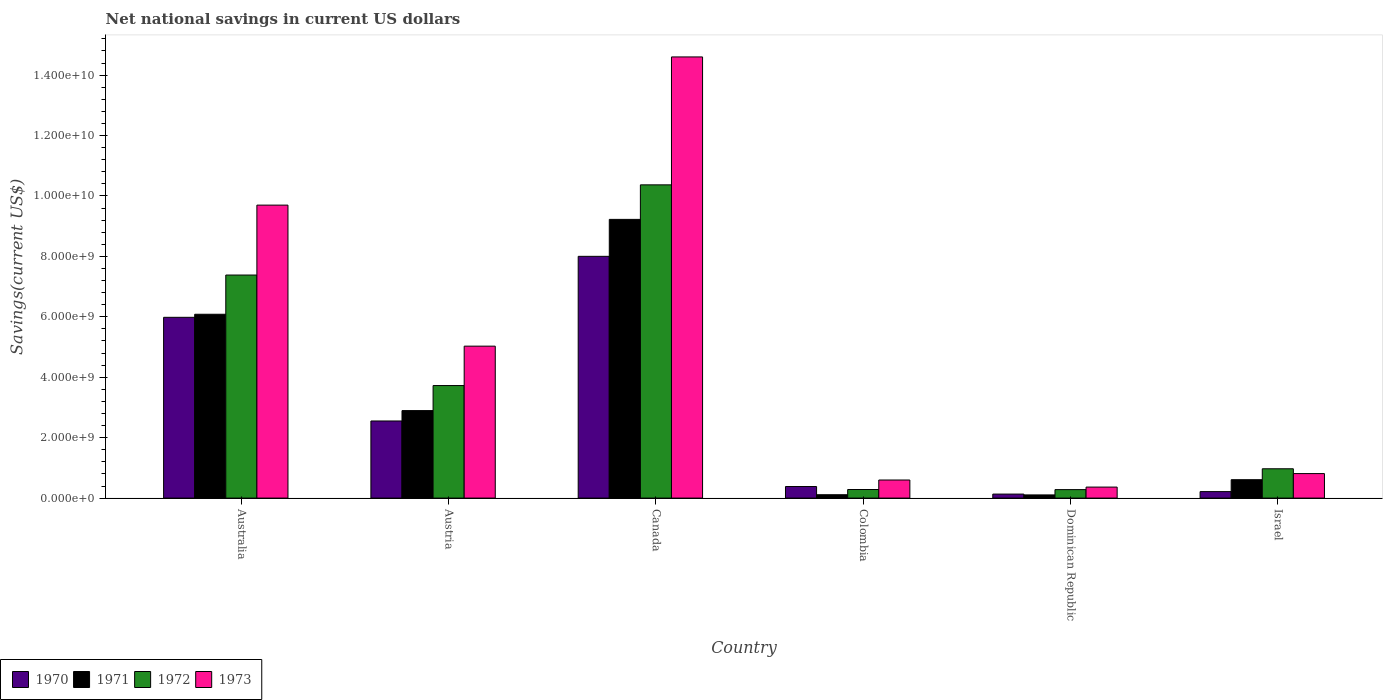How many different coloured bars are there?
Your response must be concise. 4. How many groups of bars are there?
Make the answer very short. 6. Are the number of bars on each tick of the X-axis equal?
Your answer should be compact. Yes. What is the label of the 6th group of bars from the left?
Keep it short and to the point. Israel. In how many cases, is the number of bars for a given country not equal to the number of legend labels?
Ensure brevity in your answer.  0. What is the net national savings in 1971 in Canada?
Provide a short and direct response. 9.23e+09. Across all countries, what is the maximum net national savings in 1973?
Give a very brief answer. 1.46e+1. Across all countries, what is the minimum net national savings in 1972?
Offer a very short reply. 2.80e+08. In which country was the net national savings in 1970 maximum?
Your answer should be very brief. Canada. In which country was the net national savings in 1973 minimum?
Offer a very short reply. Dominican Republic. What is the total net national savings in 1971 in the graph?
Make the answer very short. 1.90e+1. What is the difference between the net national savings in 1973 in Canada and that in Israel?
Provide a short and direct response. 1.38e+1. What is the difference between the net national savings in 1971 in Israel and the net national savings in 1970 in Dominican Republic?
Give a very brief answer. 4.76e+08. What is the average net national savings in 1972 per country?
Make the answer very short. 3.84e+09. What is the difference between the net national savings of/in 1973 and net national savings of/in 1970 in Dominican Republic?
Give a very brief answer. 2.32e+08. In how many countries, is the net national savings in 1972 greater than 9600000000 US$?
Offer a very short reply. 1. What is the ratio of the net national savings in 1972 in Canada to that in Dominican Republic?
Your answer should be very brief. 36.96. Is the net national savings in 1971 in Austria less than that in Colombia?
Keep it short and to the point. No. Is the difference between the net national savings in 1973 in Colombia and Dominican Republic greater than the difference between the net national savings in 1970 in Colombia and Dominican Republic?
Provide a succinct answer. No. What is the difference between the highest and the second highest net national savings in 1971?
Your answer should be very brief. 3.19e+09. What is the difference between the highest and the lowest net national savings in 1972?
Ensure brevity in your answer.  1.01e+1. In how many countries, is the net national savings in 1971 greater than the average net national savings in 1971 taken over all countries?
Make the answer very short. 2. Is the sum of the net national savings in 1971 in Australia and Canada greater than the maximum net national savings in 1972 across all countries?
Your answer should be very brief. Yes. What does the 3rd bar from the right in Colombia represents?
Provide a short and direct response. 1971. Are all the bars in the graph horizontal?
Your answer should be compact. No. How many countries are there in the graph?
Your answer should be very brief. 6. Are the values on the major ticks of Y-axis written in scientific E-notation?
Your answer should be compact. Yes. Does the graph contain any zero values?
Your response must be concise. No. Does the graph contain grids?
Provide a succinct answer. No. Where does the legend appear in the graph?
Make the answer very short. Bottom left. How many legend labels are there?
Your response must be concise. 4. How are the legend labels stacked?
Offer a terse response. Horizontal. What is the title of the graph?
Offer a very short reply. Net national savings in current US dollars. Does "1999" appear as one of the legend labels in the graph?
Give a very brief answer. No. What is the label or title of the Y-axis?
Your answer should be compact. Savings(current US$). What is the Savings(current US$) of 1970 in Australia?
Your answer should be very brief. 5.98e+09. What is the Savings(current US$) of 1971 in Australia?
Your response must be concise. 6.09e+09. What is the Savings(current US$) of 1972 in Australia?
Your response must be concise. 7.38e+09. What is the Savings(current US$) in 1973 in Australia?
Provide a short and direct response. 9.70e+09. What is the Savings(current US$) of 1970 in Austria?
Your answer should be very brief. 2.55e+09. What is the Savings(current US$) of 1971 in Austria?
Keep it short and to the point. 2.90e+09. What is the Savings(current US$) in 1972 in Austria?
Offer a terse response. 3.73e+09. What is the Savings(current US$) of 1973 in Austria?
Provide a succinct answer. 5.03e+09. What is the Savings(current US$) in 1970 in Canada?
Your answer should be compact. 8.00e+09. What is the Savings(current US$) in 1971 in Canada?
Provide a short and direct response. 9.23e+09. What is the Savings(current US$) in 1972 in Canada?
Your answer should be very brief. 1.04e+1. What is the Savings(current US$) in 1973 in Canada?
Provide a succinct answer. 1.46e+1. What is the Savings(current US$) in 1970 in Colombia?
Make the answer very short. 3.83e+08. What is the Savings(current US$) of 1971 in Colombia?
Keep it short and to the point. 1.11e+08. What is the Savings(current US$) in 1972 in Colombia?
Your response must be concise. 2.84e+08. What is the Savings(current US$) in 1973 in Colombia?
Make the answer very short. 5.98e+08. What is the Savings(current US$) in 1970 in Dominican Republic?
Make the answer very short. 1.33e+08. What is the Savings(current US$) of 1971 in Dominican Republic?
Provide a succinct answer. 1.05e+08. What is the Savings(current US$) of 1972 in Dominican Republic?
Your answer should be compact. 2.80e+08. What is the Savings(current US$) of 1973 in Dominican Republic?
Your answer should be very brief. 3.65e+08. What is the Savings(current US$) of 1970 in Israel?
Make the answer very short. 2.15e+08. What is the Savings(current US$) of 1971 in Israel?
Offer a terse response. 6.09e+08. What is the Savings(current US$) of 1972 in Israel?
Offer a very short reply. 9.71e+08. What is the Savings(current US$) of 1973 in Israel?
Give a very brief answer. 8.11e+08. Across all countries, what is the maximum Savings(current US$) of 1970?
Offer a terse response. 8.00e+09. Across all countries, what is the maximum Savings(current US$) in 1971?
Keep it short and to the point. 9.23e+09. Across all countries, what is the maximum Savings(current US$) in 1972?
Your response must be concise. 1.04e+1. Across all countries, what is the maximum Savings(current US$) of 1973?
Offer a terse response. 1.46e+1. Across all countries, what is the minimum Savings(current US$) in 1970?
Make the answer very short. 1.33e+08. Across all countries, what is the minimum Savings(current US$) in 1971?
Provide a succinct answer. 1.05e+08. Across all countries, what is the minimum Savings(current US$) of 1972?
Make the answer very short. 2.80e+08. Across all countries, what is the minimum Savings(current US$) of 1973?
Your response must be concise. 3.65e+08. What is the total Savings(current US$) in 1970 in the graph?
Offer a very short reply. 1.73e+1. What is the total Savings(current US$) of 1971 in the graph?
Offer a terse response. 1.90e+1. What is the total Savings(current US$) in 1972 in the graph?
Your answer should be very brief. 2.30e+1. What is the total Savings(current US$) of 1973 in the graph?
Keep it short and to the point. 3.11e+1. What is the difference between the Savings(current US$) of 1970 in Australia and that in Austria?
Provide a succinct answer. 3.43e+09. What is the difference between the Savings(current US$) of 1971 in Australia and that in Austria?
Your response must be concise. 3.19e+09. What is the difference between the Savings(current US$) of 1972 in Australia and that in Austria?
Keep it short and to the point. 3.66e+09. What is the difference between the Savings(current US$) of 1973 in Australia and that in Austria?
Provide a short and direct response. 4.67e+09. What is the difference between the Savings(current US$) of 1970 in Australia and that in Canada?
Ensure brevity in your answer.  -2.02e+09. What is the difference between the Savings(current US$) in 1971 in Australia and that in Canada?
Ensure brevity in your answer.  -3.14e+09. What is the difference between the Savings(current US$) of 1972 in Australia and that in Canada?
Your response must be concise. -2.99e+09. What is the difference between the Savings(current US$) of 1973 in Australia and that in Canada?
Your answer should be very brief. -4.90e+09. What is the difference between the Savings(current US$) of 1970 in Australia and that in Colombia?
Make the answer very short. 5.60e+09. What is the difference between the Savings(current US$) of 1971 in Australia and that in Colombia?
Offer a terse response. 5.97e+09. What is the difference between the Savings(current US$) of 1972 in Australia and that in Colombia?
Your answer should be compact. 7.10e+09. What is the difference between the Savings(current US$) in 1973 in Australia and that in Colombia?
Your response must be concise. 9.10e+09. What is the difference between the Savings(current US$) in 1970 in Australia and that in Dominican Republic?
Provide a succinct answer. 5.85e+09. What is the difference between the Savings(current US$) of 1971 in Australia and that in Dominican Republic?
Ensure brevity in your answer.  5.98e+09. What is the difference between the Savings(current US$) in 1972 in Australia and that in Dominican Republic?
Your answer should be very brief. 7.10e+09. What is the difference between the Savings(current US$) in 1973 in Australia and that in Dominican Republic?
Offer a very short reply. 9.33e+09. What is the difference between the Savings(current US$) in 1970 in Australia and that in Israel?
Provide a succinct answer. 5.77e+09. What is the difference between the Savings(current US$) in 1971 in Australia and that in Israel?
Your response must be concise. 5.48e+09. What is the difference between the Savings(current US$) in 1972 in Australia and that in Israel?
Provide a short and direct response. 6.41e+09. What is the difference between the Savings(current US$) of 1973 in Australia and that in Israel?
Offer a very short reply. 8.89e+09. What is the difference between the Savings(current US$) in 1970 in Austria and that in Canada?
Provide a succinct answer. -5.45e+09. What is the difference between the Savings(current US$) of 1971 in Austria and that in Canada?
Your answer should be compact. -6.33e+09. What is the difference between the Savings(current US$) of 1972 in Austria and that in Canada?
Give a very brief answer. -6.64e+09. What is the difference between the Savings(current US$) of 1973 in Austria and that in Canada?
Ensure brevity in your answer.  -9.57e+09. What is the difference between the Savings(current US$) of 1970 in Austria and that in Colombia?
Offer a terse response. 2.17e+09. What is the difference between the Savings(current US$) in 1971 in Austria and that in Colombia?
Offer a terse response. 2.78e+09. What is the difference between the Savings(current US$) in 1972 in Austria and that in Colombia?
Ensure brevity in your answer.  3.44e+09. What is the difference between the Savings(current US$) of 1973 in Austria and that in Colombia?
Make the answer very short. 4.43e+09. What is the difference between the Savings(current US$) of 1970 in Austria and that in Dominican Republic?
Provide a succinct answer. 2.42e+09. What is the difference between the Savings(current US$) of 1971 in Austria and that in Dominican Republic?
Make the answer very short. 2.79e+09. What is the difference between the Savings(current US$) of 1972 in Austria and that in Dominican Republic?
Provide a short and direct response. 3.44e+09. What is the difference between the Savings(current US$) in 1973 in Austria and that in Dominican Republic?
Provide a short and direct response. 4.66e+09. What is the difference between the Savings(current US$) in 1970 in Austria and that in Israel?
Give a very brief answer. 2.34e+09. What is the difference between the Savings(current US$) in 1971 in Austria and that in Israel?
Your answer should be very brief. 2.29e+09. What is the difference between the Savings(current US$) in 1972 in Austria and that in Israel?
Your answer should be very brief. 2.75e+09. What is the difference between the Savings(current US$) in 1973 in Austria and that in Israel?
Your answer should be compact. 4.22e+09. What is the difference between the Savings(current US$) of 1970 in Canada and that in Colombia?
Your answer should be very brief. 7.62e+09. What is the difference between the Savings(current US$) in 1971 in Canada and that in Colombia?
Provide a succinct answer. 9.11e+09. What is the difference between the Savings(current US$) of 1972 in Canada and that in Colombia?
Your answer should be compact. 1.01e+1. What is the difference between the Savings(current US$) of 1973 in Canada and that in Colombia?
Make the answer very short. 1.40e+1. What is the difference between the Savings(current US$) of 1970 in Canada and that in Dominican Republic?
Your response must be concise. 7.87e+09. What is the difference between the Savings(current US$) in 1971 in Canada and that in Dominican Republic?
Your answer should be very brief. 9.12e+09. What is the difference between the Savings(current US$) in 1972 in Canada and that in Dominican Republic?
Keep it short and to the point. 1.01e+1. What is the difference between the Savings(current US$) in 1973 in Canada and that in Dominican Republic?
Keep it short and to the point. 1.42e+1. What is the difference between the Savings(current US$) of 1970 in Canada and that in Israel?
Provide a short and direct response. 7.79e+09. What is the difference between the Savings(current US$) in 1971 in Canada and that in Israel?
Provide a short and direct response. 8.62e+09. What is the difference between the Savings(current US$) of 1972 in Canada and that in Israel?
Keep it short and to the point. 9.40e+09. What is the difference between the Savings(current US$) of 1973 in Canada and that in Israel?
Provide a short and direct response. 1.38e+1. What is the difference between the Savings(current US$) in 1970 in Colombia and that in Dominican Republic?
Provide a succinct answer. 2.50e+08. What is the difference between the Savings(current US$) in 1971 in Colombia and that in Dominican Republic?
Your response must be concise. 6.03e+06. What is the difference between the Savings(current US$) in 1972 in Colombia and that in Dominican Republic?
Provide a succinct answer. 3.48e+06. What is the difference between the Savings(current US$) of 1973 in Colombia and that in Dominican Republic?
Provide a succinct answer. 2.34e+08. What is the difference between the Savings(current US$) in 1970 in Colombia and that in Israel?
Your answer should be very brief. 1.68e+08. What is the difference between the Savings(current US$) of 1971 in Colombia and that in Israel?
Make the answer very short. -4.97e+08. What is the difference between the Savings(current US$) of 1972 in Colombia and that in Israel?
Provide a short and direct response. -6.87e+08. What is the difference between the Savings(current US$) in 1973 in Colombia and that in Israel?
Offer a terse response. -2.12e+08. What is the difference between the Savings(current US$) of 1970 in Dominican Republic and that in Israel?
Your response must be concise. -8.19e+07. What is the difference between the Savings(current US$) of 1971 in Dominican Republic and that in Israel?
Your answer should be very brief. -5.03e+08. What is the difference between the Savings(current US$) in 1972 in Dominican Republic and that in Israel?
Offer a terse response. -6.90e+08. What is the difference between the Savings(current US$) of 1973 in Dominican Republic and that in Israel?
Your answer should be very brief. -4.46e+08. What is the difference between the Savings(current US$) of 1970 in Australia and the Savings(current US$) of 1971 in Austria?
Provide a succinct answer. 3.09e+09. What is the difference between the Savings(current US$) of 1970 in Australia and the Savings(current US$) of 1972 in Austria?
Your response must be concise. 2.26e+09. What is the difference between the Savings(current US$) in 1970 in Australia and the Savings(current US$) in 1973 in Austria?
Offer a terse response. 9.54e+08. What is the difference between the Savings(current US$) of 1971 in Australia and the Savings(current US$) of 1972 in Austria?
Offer a very short reply. 2.36e+09. What is the difference between the Savings(current US$) of 1971 in Australia and the Savings(current US$) of 1973 in Austria?
Ensure brevity in your answer.  1.06e+09. What is the difference between the Savings(current US$) of 1972 in Australia and the Savings(current US$) of 1973 in Austria?
Ensure brevity in your answer.  2.35e+09. What is the difference between the Savings(current US$) in 1970 in Australia and the Savings(current US$) in 1971 in Canada?
Make the answer very short. -3.24e+09. What is the difference between the Savings(current US$) in 1970 in Australia and the Savings(current US$) in 1972 in Canada?
Make the answer very short. -4.38e+09. What is the difference between the Savings(current US$) of 1970 in Australia and the Savings(current US$) of 1973 in Canada?
Make the answer very short. -8.62e+09. What is the difference between the Savings(current US$) of 1971 in Australia and the Savings(current US$) of 1972 in Canada?
Provide a succinct answer. -4.28e+09. What is the difference between the Savings(current US$) in 1971 in Australia and the Savings(current US$) in 1973 in Canada?
Make the answer very short. -8.52e+09. What is the difference between the Savings(current US$) in 1972 in Australia and the Savings(current US$) in 1973 in Canada?
Offer a very short reply. -7.22e+09. What is the difference between the Savings(current US$) of 1970 in Australia and the Savings(current US$) of 1971 in Colombia?
Provide a short and direct response. 5.87e+09. What is the difference between the Savings(current US$) in 1970 in Australia and the Savings(current US$) in 1972 in Colombia?
Your answer should be very brief. 5.70e+09. What is the difference between the Savings(current US$) in 1970 in Australia and the Savings(current US$) in 1973 in Colombia?
Keep it short and to the point. 5.38e+09. What is the difference between the Savings(current US$) in 1971 in Australia and the Savings(current US$) in 1972 in Colombia?
Your answer should be very brief. 5.80e+09. What is the difference between the Savings(current US$) of 1971 in Australia and the Savings(current US$) of 1973 in Colombia?
Your answer should be very brief. 5.49e+09. What is the difference between the Savings(current US$) in 1972 in Australia and the Savings(current US$) in 1973 in Colombia?
Give a very brief answer. 6.78e+09. What is the difference between the Savings(current US$) in 1970 in Australia and the Savings(current US$) in 1971 in Dominican Republic?
Provide a short and direct response. 5.88e+09. What is the difference between the Savings(current US$) in 1970 in Australia and the Savings(current US$) in 1972 in Dominican Republic?
Provide a succinct answer. 5.70e+09. What is the difference between the Savings(current US$) of 1970 in Australia and the Savings(current US$) of 1973 in Dominican Republic?
Your answer should be compact. 5.62e+09. What is the difference between the Savings(current US$) in 1971 in Australia and the Savings(current US$) in 1972 in Dominican Republic?
Make the answer very short. 5.80e+09. What is the difference between the Savings(current US$) of 1971 in Australia and the Savings(current US$) of 1973 in Dominican Republic?
Your answer should be very brief. 5.72e+09. What is the difference between the Savings(current US$) in 1972 in Australia and the Savings(current US$) in 1973 in Dominican Republic?
Keep it short and to the point. 7.02e+09. What is the difference between the Savings(current US$) in 1970 in Australia and the Savings(current US$) in 1971 in Israel?
Offer a very short reply. 5.37e+09. What is the difference between the Savings(current US$) of 1970 in Australia and the Savings(current US$) of 1972 in Israel?
Your answer should be very brief. 5.01e+09. What is the difference between the Savings(current US$) in 1970 in Australia and the Savings(current US$) in 1973 in Israel?
Offer a very short reply. 5.17e+09. What is the difference between the Savings(current US$) of 1971 in Australia and the Savings(current US$) of 1972 in Israel?
Provide a succinct answer. 5.11e+09. What is the difference between the Savings(current US$) in 1971 in Australia and the Savings(current US$) in 1973 in Israel?
Give a very brief answer. 5.27e+09. What is the difference between the Savings(current US$) in 1972 in Australia and the Savings(current US$) in 1973 in Israel?
Your answer should be very brief. 6.57e+09. What is the difference between the Savings(current US$) of 1970 in Austria and the Savings(current US$) of 1971 in Canada?
Provide a succinct answer. -6.67e+09. What is the difference between the Savings(current US$) in 1970 in Austria and the Savings(current US$) in 1972 in Canada?
Ensure brevity in your answer.  -7.82e+09. What is the difference between the Savings(current US$) of 1970 in Austria and the Savings(current US$) of 1973 in Canada?
Your answer should be very brief. -1.20e+1. What is the difference between the Savings(current US$) in 1971 in Austria and the Savings(current US$) in 1972 in Canada?
Your answer should be very brief. -7.47e+09. What is the difference between the Savings(current US$) of 1971 in Austria and the Savings(current US$) of 1973 in Canada?
Keep it short and to the point. -1.17e+1. What is the difference between the Savings(current US$) of 1972 in Austria and the Savings(current US$) of 1973 in Canada?
Your response must be concise. -1.09e+1. What is the difference between the Savings(current US$) in 1970 in Austria and the Savings(current US$) in 1971 in Colombia?
Offer a very short reply. 2.44e+09. What is the difference between the Savings(current US$) in 1970 in Austria and the Savings(current US$) in 1972 in Colombia?
Your answer should be very brief. 2.27e+09. What is the difference between the Savings(current US$) in 1970 in Austria and the Savings(current US$) in 1973 in Colombia?
Your answer should be compact. 1.95e+09. What is the difference between the Savings(current US$) of 1971 in Austria and the Savings(current US$) of 1972 in Colombia?
Keep it short and to the point. 2.61e+09. What is the difference between the Savings(current US$) of 1971 in Austria and the Savings(current US$) of 1973 in Colombia?
Give a very brief answer. 2.30e+09. What is the difference between the Savings(current US$) of 1972 in Austria and the Savings(current US$) of 1973 in Colombia?
Offer a terse response. 3.13e+09. What is the difference between the Savings(current US$) of 1970 in Austria and the Savings(current US$) of 1971 in Dominican Republic?
Make the answer very short. 2.45e+09. What is the difference between the Savings(current US$) in 1970 in Austria and the Savings(current US$) in 1972 in Dominican Republic?
Give a very brief answer. 2.27e+09. What is the difference between the Savings(current US$) of 1970 in Austria and the Savings(current US$) of 1973 in Dominican Republic?
Offer a terse response. 2.19e+09. What is the difference between the Savings(current US$) of 1971 in Austria and the Savings(current US$) of 1972 in Dominican Republic?
Make the answer very short. 2.62e+09. What is the difference between the Savings(current US$) in 1971 in Austria and the Savings(current US$) in 1973 in Dominican Republic?
Offer a very short reply. 2.53e+09. What is the difference between the Savings(current US$) in 1972 in Austria and the Savings(current US$) in 1973 in Dominican Republic?
Offer a terse response. 3.36e+09. What is the difference between the Savings(current US$) of 1970 in Austria and the Savings(current US$) of 1971 in Israel?
Your response must be concise. 1.94e+09. What is the difference between the Savings(current US$) of 1970 in Austria and the Savings(current US$) of 1972 in Israel?
Offer a terse response. 1.58e+09. What is the difference between the Savings(current US$) of 1970 in Austria and the Savings(current US$) of 1973 in Israel?
Keep it short and to the point. 1.74e+09. What is the difference between the Savings(current US$) in 1971 in Austria and the Savings(current US$) in 1972 in Israel?
Make the answer very short. 1.93e+09. What is the difference between the Savings(current US$) of 1971 in Austria and the Savings(current US$) of 1973 in Israel?
Offer a very short reply. 2.09e+09. What is the difference between the Savings(current US$) of 1972 in Austria and the Savings(current US$) of 1973 in Israel?
Ensure brevity in your answer.  2.91e+09. What is the difference between the Savings(current US$) in 1970 in Canada and the Savings(current US$) in 1971 in Colombia?
Offer a very short reply. 7.89e+09. What is the difference between the Savings(current US$) in 1970 in Canada and the Savings(current US$) in 1972 in Colombia?
Provide a short and direct response. 7.72e+09. What is the difference between the Savings(current US$) of 1970 in Canada and the Savings(current US$) of 1973 in Colombia?
Provide a short and direct response. 7.40e+09. What is the difference between the Savings(current US$) in 1971 in Canada and the Savings(current US$) in 1972 in Colombia?
Your answer should be compact. 8.94e+09. What is the difference between the Savings(current US$) of 1971 in Canada and the Savings(current US$) of 1973 in Colombia?
Make the answer very short. 8.63e+09. What is the difference between the Savings(current US$) of 1972 in Canada and the Savings(current US$) of 1973 in Colombia?
Offer a terse response. 9.77e+09. What is the difference between the Savings(current US$) of 1970 in Canada and the Savings(current US$) of 1971 in Dominican Republic?
Provide a succinct answer. 7.90e+09. What is the difference between the Savings(current US$) in 1970 in Canada and the Savings(current US$) in 1972 in Dominican Republic?
Your answer should be compact. 7.72e+09. What is the difference between the Savings(current US$) in 1970 in Canada and the Savings(current US$) in 1973 in Dominican Republic?
Give a very brief answer. 7.64e+09. What is the difference between the Savings(current US$) in 1971 in Canada and the Savings(current US$) in 1972 in Dominican Republic?
Give a very brief answer. 8.94e+09. What is the difference between the Savings(current US$) of 1971 in Canada and the Savings(current US$) of 1973 in Dominican Republic?
Your answer should be compact. 8.86e+09. What is the difference between the Savings(current US$) in 1972 in Canada and the Savings(current US$) in 1973 in Dominican Republic?
Keep it short and to the point. 1.00e+1. What is the difference between the Savings(current US$) in 1970 in Canada and the Savings(current US$) in 1971 in Israel?
Offer a very short reply. 7.39e+09. What is the difference between the Savings(current US$) of 1970 in Canada and the Savings(current US$) of 1972 in Israel?
Your response must be concise. 7.03e+09. What is the difference between the Savings(current US$) in 1970 in Canada and the Savings(current US$) in 1973 in Israel?
Your answer should be compact. 7.19e+09. What is the difference between the Savings(current US$) of 1971 in Canada and the Savings(current US$) of 1972 in Israel?
Your answer should be very brief. 8.25e+09. What is the difference between the Savings(current US$) of 1971 in Canada and the Savings(current US$) of 1973 in Israel?
Your answer should be very brief. 8.41e+09. What is the difference between the Savings(current US$) of 1972 in Canada and the Savings(current US$) of 1973 in Israel?
Your answer should be very brief. 9.56e+09. What is the difference between the Savings(current US$) of 1970 in Colombia and the Savings(current US$) of 1971 in Dominican Republic?
Provide a short and direct response. 2.77e+08. What is the difference between the Savings(current US$) in 1970 in Colombia and the Savings(current US$) in 1972 in Dominican Republic?
Ensure brevity in your answer.  1.02e+08. What is the difference between the Savings(current US$) of 1970 in Colombia and the Savings(current US$) of 1973 in Dominican Republic?
Give a very brief answer. 1.82e+07. What is the difference between the Savings(current US$) in 1971 in Colombia and the Savings(current US$) in 1972 in Dominican Republic?
Provide a short and direct response. -1.69e+08. What is the difference between the Savings(current US$) in 1971 in Colombia and the Savings(current US$) in 1973 in Dominican Republic?
Offer a very short reply. -2.53e+08. What is the difference between the Savings(current US$) in 1972 in Colombia and the Savings(current US$) in 1973 in Dominican Republic?
Your answer should be compact. -8.05e+07. What is the difference between the Savings(current US$) of 1970 in Colombia and the Savings(current US$) of 1971 in Israel?
Offer a very short reply. -2.26e+08. What is the difference between the Savings(current US$) of 1970 in Colombia and the Savings(current US$) of 1972 in Israel?
Provide a succinct answer. -5.88e+08. What is the difference between the Savings(current US$) of 1970 in Colombia and the Savings(current US$) of 1973 in Israel?
Ensure brevity in your answer.  -4.28e+08. What is the difference between the Savings(current US$) of 1971 in Colombia and the Savings(current US$) of 1972 in Israel?
Offer a very short reply. -8.59e+08. What is the difference between the Savings(current US$) of 1971 in Colombia and the Savings(current US$) of 1973 in Israel?
Offer a very short reply. -6.99e+08. What is the difference between the Savings(current US$) of 1972 in Colombia and the Savings(current US$) of 1973 in Israel?
Your response must be concise. -5.27e+08. What is the difference between the Savings(current US$) in 1970 in Dominican Republic and the Savings(current US$) in 1971 in Israel?
Give a very brief answer. -4.76e+08. What is the difference between the Savings(current US$) of 1970 in Dominican Republic and the Savings(current US$) of 1972 in Israel?
Your response must be concise. -8.38e+08. What is the difference between the Savings(current US$) of 1970 in Dominican Republic and the Savings(current US$) of 1973 in Israel?
Provide a short and direct response. -6.78e+08. What is the difference between the Savings(current US$) in 1971 in Dominican Republic and the Savings(current US$) in 1972 in Israel?
Your answer should be compact. -8.65e+08. What is the difference between the Savings(current US$) of 1971 in Dominican Republic and the Savings(current US$) of 1973 in Israel?
Your answer should be very brief. -7.05e+08. What is the difference between the Savings(current US$) in 1972 in Dominican Republic and the Savings(current US$) in 1973 in Israel?
Provide a succinct answer. -5.30e+08. What is the average Savings(current US$) in 1970 per country?
Make the answer very short. 2.88e+09. What is the average Savings(current US$) in 1971 per country?
Your response must be concise. 3.17e+09. What is the average Savings(current US$) in 1972 per country?
Ensure brevity in your answer.  3.84e+09. What is the average Savings(current US$) in 1973 per country?
Give a very brief answer. 5.18e+09. What is the difference between the Savings(current US$) in 1970 and Savings(current US$) in 1971 in Australia?
Provide a short and direct response. -1.02e+08. What is the difference between the Savings(current US$) in 1970 and Savings(current US$) in 1972 in Australia?
Keep it short and to the point. -1.40e+09. What is the difference between the Savings(current US$) of 1970 and Savings(current US$) of 1973 in Australia?
Provide a short and direct response. -3.71e+09. What is the difference between the Savings(current US$) in 1971 and Savings(current US$) in 1972 in Australia?
Ensure brevity in your answer.  -1.30e+09. What is the difference between the Savings(current US$) of 1971 and Savings(current US$) of 1973 in Australia?
Your response must be concise. -3.61e+09. What is the difference between the Savings(current US$) in 1972 and Savings(current US$) in 1973 in Australia?
Offer a terse response. -2.31e+09. What is the difference between the Savings(current US$) of 1970 and Savings(current US$) of 1971 in Austria?
Your answer should be compact. -3.44e+08. What is the difference between the Savings(current US$) of 1970 and Savings(current US$) of 1972 in Austria?
Provide a succinct answer. -1.17e+09. What is the difference between the Savings(current US$) of 1970 and Savings(current US$) of 1973 in Austria?
Keep it short and to the point. -2.48e+09. What is the difference between the Savings(current US$) in 1971 and Savings(current US$) in 1972 in Austria?
Ensure brevity in your answer.  -8.29e+08. What is the difference between the Savings(current US$) of 1971 and Savings(current US$) of 1973 in Austria?
Make the answer very short. -2.13e+09. What is the difference between the Savings(current US$) of 1972 and Savings(current US$) of 1973 in Austria?
Provide a short and direct response. -1.30e+09. What is the difference between the Savings(current US$) of 1970 and Savings(current US$) of 1971 in Canada?
Make the answer very short. -1.22e+09. What is the difference between the Savings(current US$) in 1970 and Savings(current US$) in 1972 in Canada?
Offer a very short reply. -2.37e+09. What is the difference between the Savings(current US$) of 1970 and Savings(current US$) of 1973 in Canada?
Offer a very short reply. -6.60e+09. What is the difference between the Savings(current US$) in 1971 and Savings(current US$) in 1972 in Canada?
Give a very brief answer. -1.14e+09. What is the difference between the Savings(current US$) of 1971 and Savings(current US$) of 1973 in Canada?
Your response must be concise. -5.38e+09. What is the difference between the Savings(current US$) of 1972 and Savings(current US$) of 1973 in Canada?
Offer a very short reply. -4.23e+09. What is the difference between the Savings(current US$) of 1970 and Savings(current US$) of 1971 in Colombia?
Your answer should be compact. 2.71e+08. What is the difference between the Savings(current US$) in 1970 and Savings(current US$) in 1972 in Colombia?
Your answer should be compact. 9.87e+07. What is the difference between the Savings(current US$) in 1970 and Savings(current US$) in 1973 in Colombia?
Provide a short and direct response. -2.16e+08. What is the difference between the Savings(current US$) of 1971 and Savings(current US$) of 1972 in Colombia?
Ensure brevity in your answer.  -1.73e+08. What is the difference between the Savings(current US$) in 1971 and Savings(current US$) in 1973 in Colombia?
Make the answer very short. -4.87e+08. What is the difference between the Savings(current US$) in 1972 and Savings(current US$) in 1973 in Colombia?
Make the answer very short. -3.14e+08. What is the difference between the Savings(current US$) of 1970 and Savings(current US$) of 1971 in Dominican Republic?
Your response must be concise. 2.74e+07. What is the difference between the Savings(current US$) of 1970 and Savings(current US$) of 1972 in Dominican Republic?
Provide a succinct answer. -1.48e+08. What is the difference between the Savings(current US$) in 1970 and Savings(current US$) in 1973 in Dominican Republic?
Offer a terse response. -2.32e+08. What is the difference between the Savings(current US$) of 1971 and Savings(current US$) of 1972 in Dominican Republic?
Provide a short and direct response. -1.75e+08. What is the difference between the Savings(current US$) of 1971 and Savings(current US$) of 1973 in Dominican Republic?
Give a very brief answer. -2.59e+08. What is the difference between the Savings(current US$) in 1972 and Savings(current US$) in 1973 in Dominican Republic?
Give a very brief answer. -8.40e+07. What is the difference between the Savings(current US$) of 1970 and Savings(current US$) of 1971 in Israel?
Your answer should be very brief. -3.94e+08. What is the difference between the Savings(current US$) in 1970 and Savings(current US$) in 1972 in Israel?
Ensure brevity in your answer.  -7.56e+08. What is the difference between the Savings(current US$) of 1970 and Savings(current US$) of 1973 in Israel?
Offer a terse response. -5.96e+08. What is the difference between the Savings(current US$) of 1971 and Savings(current US$) of 1972 in Israel?
Make the answer very short. -3.62e+08. What is the difference between the Savings(current US$) of 1971 and Savings(current US$) of 1973 in Israel?
Your answer should be compact. -2.02e+08. What is the difference between the Savings(current US$) in 1972 and Savings(current US$) in 1973 in Israel?
Ensure brevity in your answer.  1.60e+08. What is the ratio of the Savings(current US$) of 1970 in Australia to that in Austria?
Ensure brevity in your answer.  2.34. What is the ratio of the Savings(current US$) of 1971 in Australia to that in Austria?
Provide a succinct answer. 2.1. What is the ratio of the Savings(current US$) of 1972 in Australia to that in Austria?
Your answer should be compact. 1.98. What is the ratio of the Savings(current US$) in 1973 in Australia to that in Austria?
Keep it short and to the point. 1.93. What is the ratio of the Savings(current US$) in 1970 in Australia to that in Canada?
Make the answer very short. 0.75. What is the ratio of the Savings(current US$) in 1971 in Australia to that in Canada?
Offer a very short reply. 0.66. What is the ratio of the Savings(current US$) in 1972 in Australia to that in Canada?
Provide a short and direct response. 0.71. What is the ratio of the Savings(current US$) in 1973 in Australia to that in Canada?
Offer a terse response. 0.66. What is the ratio of the Savings(current US$) of 1970 in Australia to that in Colombia?
Your answer should be very brief. 15.64. What is the ratio of the Savings(current US$) in 1971 in Australia to that in Colombia?
Ensure brevity in your answer.  54.61. What is the ratio of the Savings(current US$) of 1972 in Australia to that in Colombia?
Your response must be concise. 26. What is the ratio of the Savings(current US$) of 1973 in Australia to that in Colombia?
Provide a succinct answer. 16.2. What is the ratio of the Savings(current US$) of 1970 in Australia to that in Dominican Republic?
Provide a short and direct response. 45.07. What is the ratio of the Savings(current US$) of 1971 in Australia to that in Dominican Republic?
Ensure brevity in your answer.  57.73. What is the ratio of the Savings(current US$) of 1972 in Australia to that in Dominican Republic?
Give a very brief answer. 26.32. What is the ratio of the Savings(current US$) in 1973 in Australia to that in Dominican Republic?
Your answer should be compact. 26.6. What is the ratio of the Savings(current US$) in 1970 in Australia to that in Israel?
Your response must be concise. 27.88. What is the ratio of the Savings(current US$) of 1971 in Australia to that in Israel?
Your response must be concise. 10. What is the ratio of the Savings(current US$) in 1972 in Australia to that in Israel?
Your response must be concise. 7.61. What is the ratio of the Savings(current US$) in 1973 in Australia to that in Israel?
Provide a succinct answer. 11.96. What is the ratio of the Savings(current US$) of 1970 in Austria to that in Canada?
Provide a succinct answer. 0.32. What is the ratio of the Savings(current US$) of 1971 in Austria to that in Canada?
Your answer should be compact. 0.31. What is the ratio of the Savings(current US$) in 1972 in Austria to that in Canada?
Ensure brevity in your answer.  0.36. What is the ratio of the Savings(current US$) of 1973 in Austria to that in Canada?
Provide a succinct answer. 0.34. What is the ratio of the Savings(current US$) of 1970 in Austria to that in Colombia?
Offer a very short reply. 6.67. What is the ratio of the Savings(current US$) in 1971 in Austria to that in Colombia?
Provide a short and direct response. 25.99. What is the ratio of the Savings(current US$) in 1972 in Austria to that in Colombia?
Offer a terse response. 13.12. What is the ratio of the Savings(current US$) of 1973 in Austria to that in Colombia?
Offer a very short reply. 8.4. What is the ratio of the Savings(current US$) in 1970 in Austria to that in Dominican Republic?
Ensure brevity in your answer.  19.23. What is the ratio of the Savings(current US$) in 1971 in Austria to that in Dominican Republic?
Give a very brief answer. 27.48. What is the ratio of the Savings(current US$) in 1972 in Austria to that in Dominican Republic?
Ensure brevity in your answer.  13.28. What is the ratio of the Savings(current US$) in 1973 in Austria to that in Dominican Republic?
Ensure brevity in your answer.  13.8. What is the ratio of the Savings(current US$) of 1970 in Austria to that in Israel?
Your response must be concise. 11.89. What is the ratio of the Savings(current US$) of 1971 in Austria to that in Israel?
Give a very brief answer. 4.76. What is the ratio of the Savings(current US$) of 1972 in Austria to that in Israel?
Your response must be concise. 3.84. What is the ratio of the Savings(current US$) in 1973 in Austria to that in Israel?
Offer a very short reply. 6.2. What is the ratio of the Savings(current US$) of 1970 in Canada to that in Colombia?
Ensure brevity in your answer.  20.91. What is the ratio of the Savings(current US$) of 1971 in Canada to that in Colombia?
Ensure brevity in your answer.  82.79. What is the ratio of the Savings(current US$) of 1972 in Canada to that in Colombia?
Your response must be concise. 36.51. What is the ratio of the Savings(current US$) of 1973 in Canada to that in Colombia?
Provide a short and direct response. 24.4. What is the ratio of the Savings(current US$) of 1970 in Canada to that in Dominican Republic?
Give a very brief answer. 60.27. What is the ratio of the Savings(current US$) in 1971 in Canada to that in Dominican Republic?
Ensure brevity in your answer.  87.52. What is the ratio of the Savings(current US$) in 1972 in Canada to that in Dominican Republic?
Your response must be concise. 36.96. What is the ratio of the Savings(current US$) of 1973 in Canada to that in Dominican Republic?
Offer a very short reply. 40.06. What is the ratio of the Savings(current US$) in 1970 in Canada to that in Israel?
Your answer should be very brief. 37.28. What is the ratio of the Savings(current US$) in 1971 in Canada to that in Israel?
Provide a short and direct response. 15.16. What is the ratio of the Savings(current US$) of 1972 in Canada to that in Israel?
Keep it short and to the point. 10.68. What is the ratio of the Savings(current US$) of 1973 in Canada to that in Israel?
Your answer should be compact. 18.01. What is the ratio of the Savings(current US$) of 1970 in Colombia to that in Dominican Republic?
Provide a succinct answer. 2.88. What is the ratio of the Savings(current US$) in 1971 in Colombia to that in Dominican Republic?
Your response must be concise. 1.06. What is the ratio of the Savings(current US$) in 1972 in Colombia to that in Dominican Republic?
Provide a short and direct response. 1.01. What is the ratio of the Savings(current US$) in 1973 in Colombia to that in Dominican Republic?
Keep it short and to the point. 1.64. What is the ratio of the Savings(current US$) in 1970 in Colombia to that in Israel?
Provide a short and direct response. 1.78. What is the ratio of the Savings(current US$) of 1971 in Colombia to that in Israel?
Your answer should be compact. 0.18. What is the ratio of the Savings(current US$) in 1972 in Colombia to that in Israel?
Provide a succinct answer. 0.29. What is the ratio of the Savings(current US$) in 1973 in Colombia to that in Israel?
Offer a very short reply. 0.74. What is the ratio of the Savings(current US$) of 1970 in Dominican Republic to that in Israel?
Provide a succinct answer. 0.62. What is the ratio of the Savings(current US$) of 1971 in Dominican Republic to that in Israel?
Provide a succinct answer. 0.17. What is the ratio of the Savings(current US$) in 1972 in Dominican Republic to that in Israel?
Make the answer very short. 0.29. What is the ratio of the Savings(current US$) in 1973 in Dominican Republic to that in Israel?
Make the answer very short. 0.45. What is the difference between the highest and the second highest Savings(current US$) in 1970?
Your response must be concise. 2.02e+09. What is the difference between the highest and the second highest Savings(current US$) in 1971?
Give a very brief answer. 3.14e+09. What is the difference between the highest and the second highest Savings(current US$) of 1972?
Your answer should be very brief. 2.99e+09. What is the difference between the highest and the second highest Savings(current US$) of 1973?
Give a very brief answer. 4.90e+09. What is the difference between the highest and the lowest Savings(current US$) in 1970?
Provide a short and direct response. 7.87e+09. What is the difference between the highest and the lowest Savings(current US$) of 1971?
Give a very brief answer. 9.12e+09. What is the difference between the highest and the lowest Savings(current US$) of 1972?
Provide a succinct answer. 1.01e+1. What is the difference between the highest and the lowest Savings(current US$) of 1973?
Ensure brevity in your answer.  1.42e+1. 